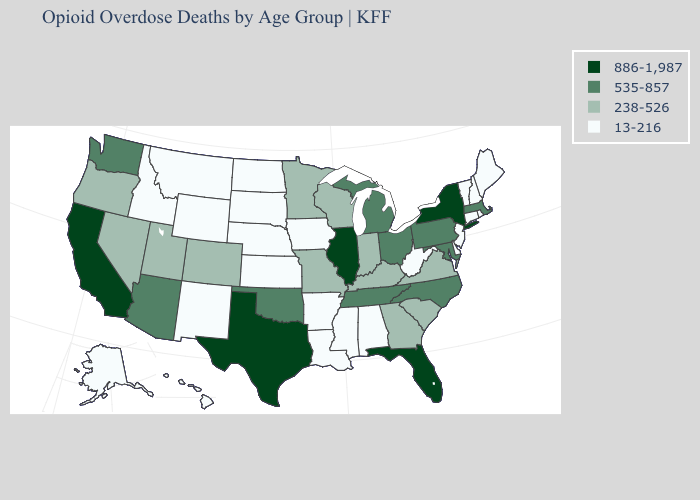How many symbols are there in the legend?
Give a very brief answer. 4. Does the first symbol in the legend represent the smallest category?
Keep it brief. No. Name the states that have a value in the range 238-526?
Keep it brief. Colorado, Georgia, Indiana, Kentucky, Minnesota, Missouri, Nevada, Oregon, South Carolina, Utah, Virginia, Wisconsin. What is the value of Colorado?
Write a very short answer. 238-526. Name the states that have a value in the range 886-1,987?
Concise answer only. California, Florida, Illinois, New York, Texas. Does the first symbol in the legend represent the smallest category?
Be succinct. No. Does Tennessee have the highest value in the USA?
Quick response, please. No. What is the lowest value in states that border South Dakota?
Write a very short answer. 13-216. Name the states that have a value in the range 13-216?
Write a very short answer. Alabama, Alaska, Arkansas, Connecticut, Delaware, Hawaii, Idaho, Iowa, Kansas, Louisiana, Maine, Mississippi, Montana, Nebraska, New Hampshire, New Jersey, New Mexico, North Dakota, Rhode Island, South Dakota, Vermont, West Virginia, Wyoming. What is the value of Missouri?
Write a very short answer. 238-526. What is the lowest value in states that border Oklahoma?
Write a very short answer. 13-216. Which states hav the highest value in the MidWest?
Write a very short answer. Illinois. Name the states that have a value in the range 238-526?
Quick response, please. Colorado, Georgia, Indiana, Kentucky, Minnesota, Missouri, Nevada, Oregon, South Carolina, Utah, Virginia, Wisconsin. Does New Mexico have a lower value than Ohio?
Quick response, please. Yes. What is the value of Wyoming?
Answer briefly. 13-216. 